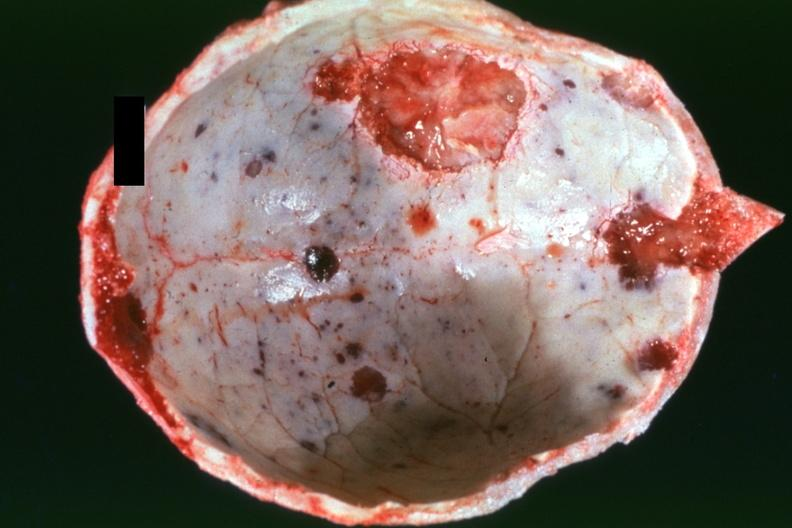what is present?
Answer the question using a single word or phrase. Bone 